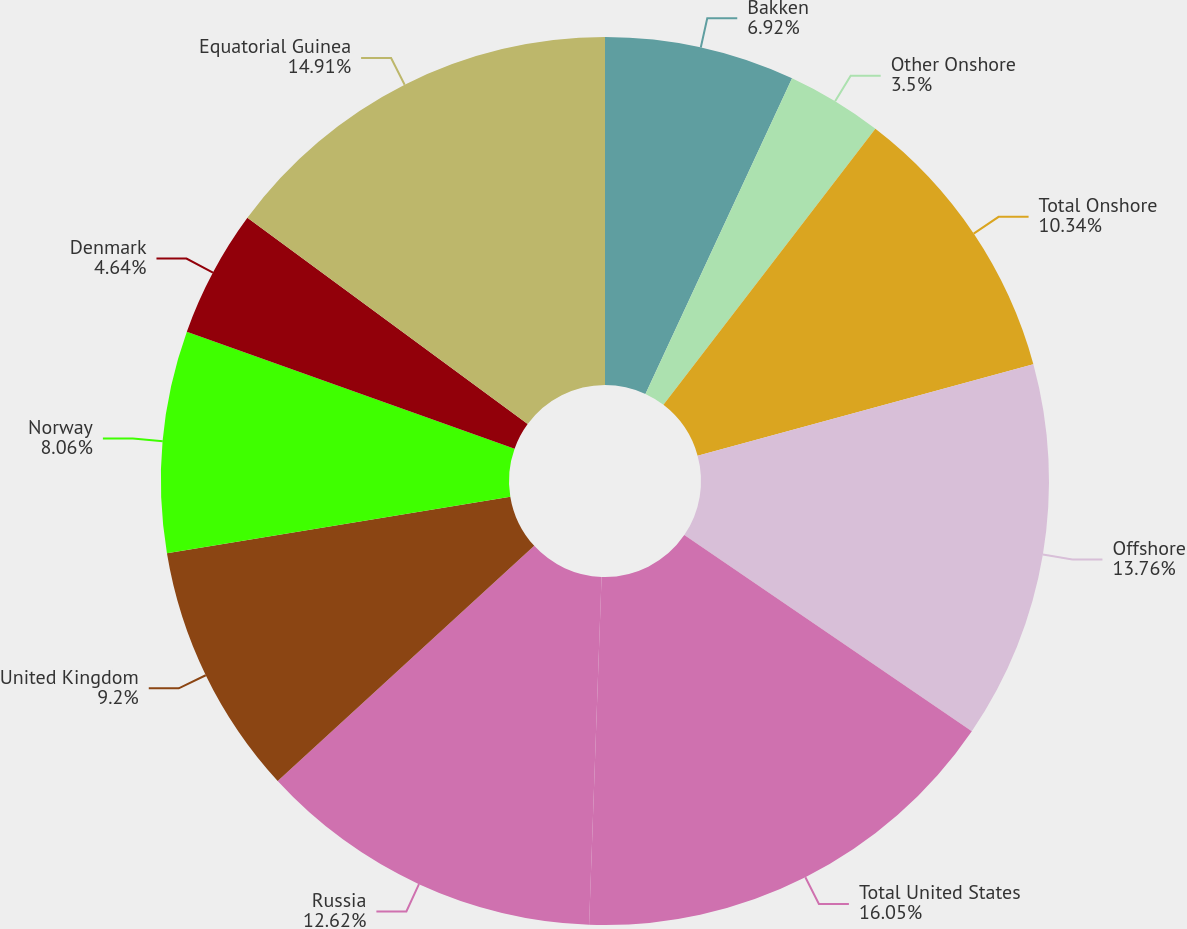Convert chart. <chart><loc_0><loc_0><loc_500><loc_500><pie_chart><fcel>Bakken<fcel>Other Onshore<fcel>Total Onshore<fcel>Offshore<fcel>Total United States<fcel>Russia<fcel>United Kingdom<fcel>Norway<fcel>Denmark<fcel>Equatorial Guinea<nl><fcel>6.92%<fcel>3.5%<fcel>10.34%<fcel>13.76%<fcel>16.04%<fcel>12.62%<fcel>9.2%<fcel>8.06%<fcel>4.64%<fcel>14.9%<nl></chart> 